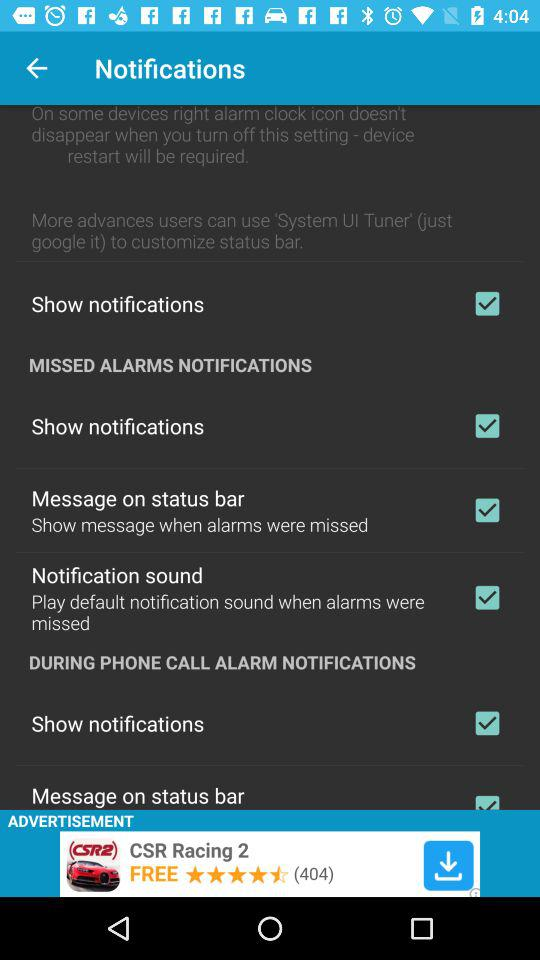What is the status of the "Message on status bar"? The status is "on". 